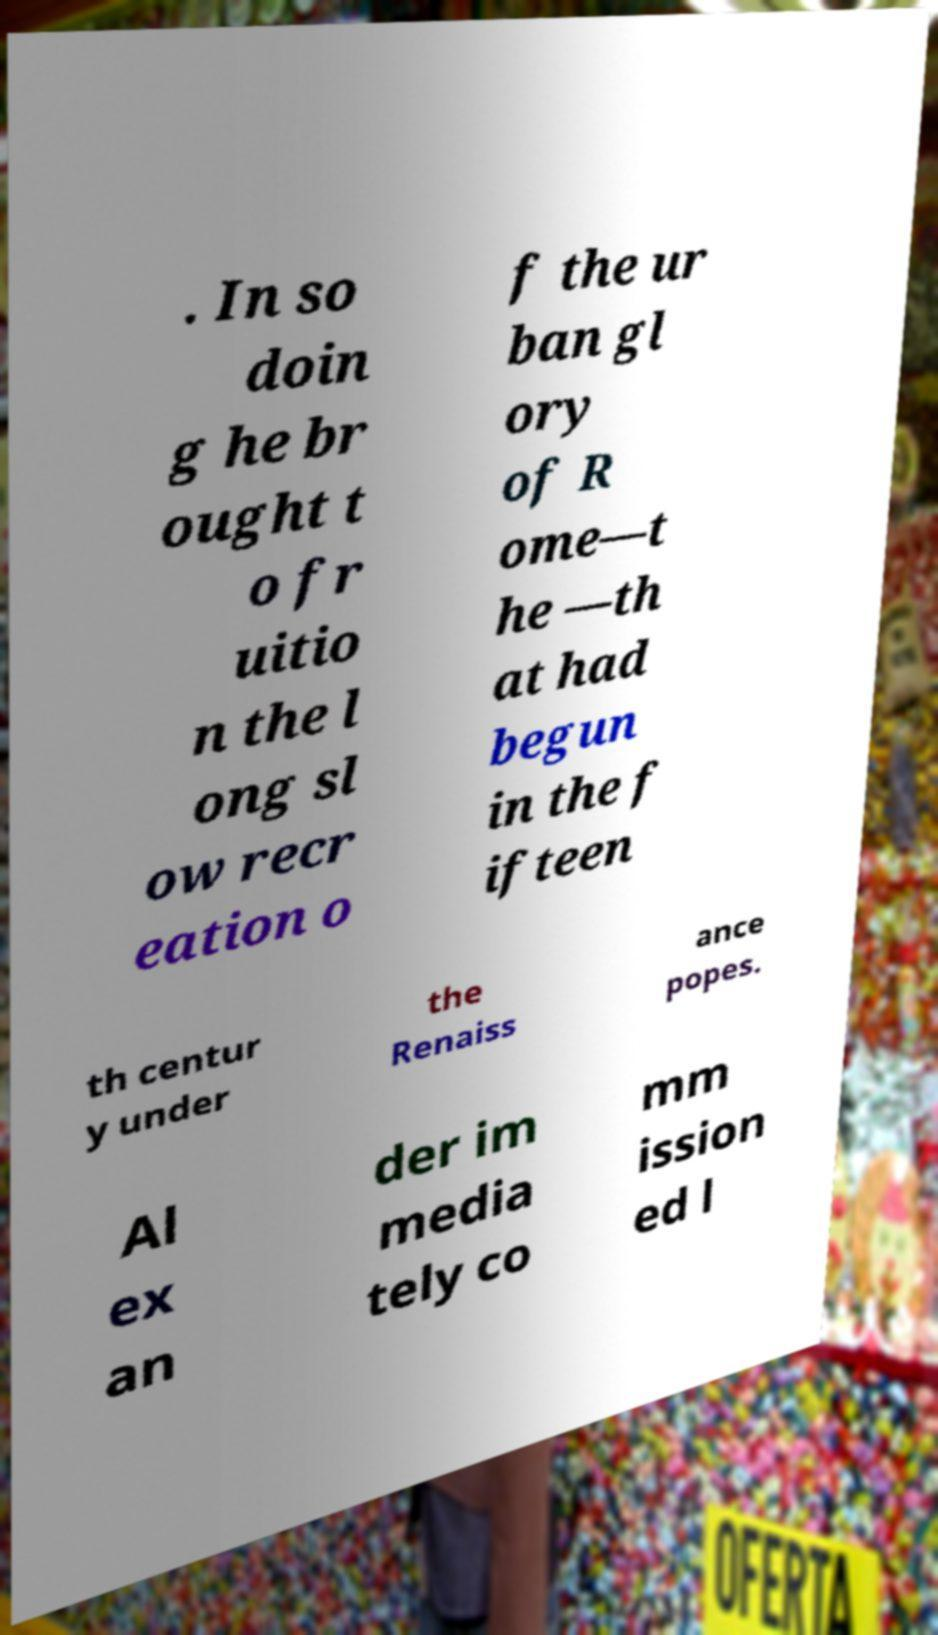Please identify and transcribe the text found in this image. . In so doin g he br ought t o fr uitio n the l ong sl ow recr eation o f the ur ban gl ory of R ome—t he —th at had begun in the f ifteen th centur y under the Renaiss ance popes. Al ex an der im media tely co mm ission ed l 